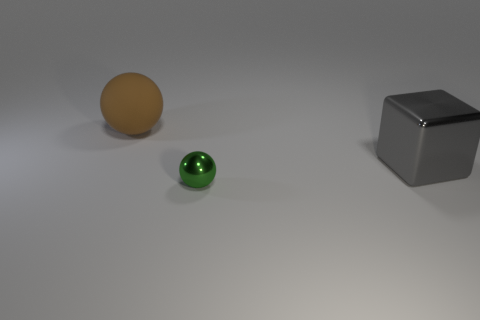What color is the shiny object that is behind the sphere in front of the big thing behind the big metal object?
Make the answer very short. Gray. What shape is the green shiny thing?
Give a very brief answer. Sphere. Are there the same number of gray shiny blocks left of the brown object and shiny spheres?
Ensure brevity in your answer.  No. How many metallic spheres have the same size as the rubber object?
Offer a very short reply. 0. Is there a large yellow rubber block?
Give a very brief answer. No. Do the metal thing that is behind the small metal ball and the object that is to the left of the small metal ball have the same shape?
Offer a very short reply. No. What number of large things are yellow things or rubber spheres?
Keep it short and to the point. 1. What shape is the other gray object that is made of the same material as the small thing?
Make the answer very short. Cube. Do the brown rubber thing and the tiny thing have the same shape?
Give a very brief answer. Yes. The rubber thing has what color?
Offer a terse response. Brown. 